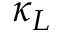<formula> <loc_0><loc_0><loc_500><loc_500>\kappa _ { L }</formula> 